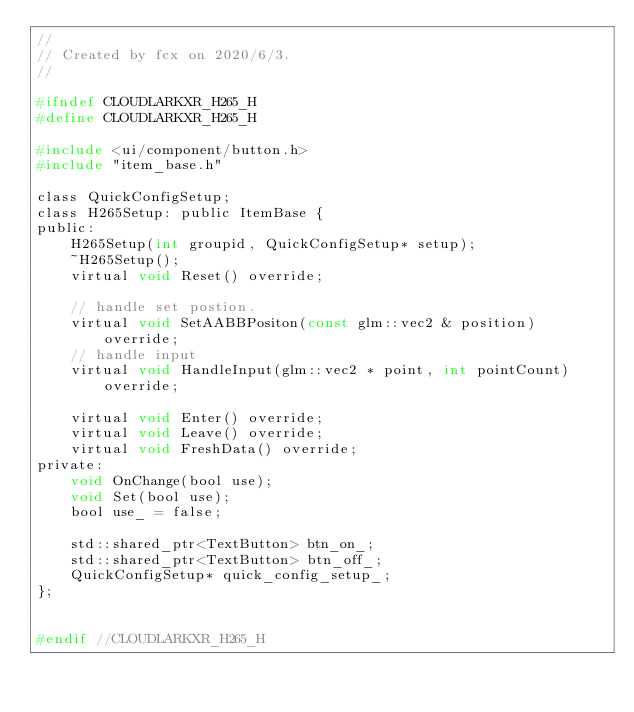Convert code to text. <code><loc_0><loc_0><loc_500><loc_500><_C_>//
// Created by fcx on 2020/6/3.
//

#ifndef CLOUDLARKXR_H265_H
#define CLOUDLARKXR_H265_H

#include <ui/component/button.h>
#include "item_base.h"

class QuickConfigSetup;
class H265Setup: public ItemBase {
public:
    H265Setup(int groupid, QuickConfigSetup* setup);
    ~H265Setup();
    virtual void Reset() override;

    // handle set postion.
    virtual void SetAABBPositon(const glm::vec2 & position) override;
    // handle input
    virtual void HandleInput(glm::vec2 * point, int pointCount) override;

    virtual void Enter() override;
    virtual void Leave() override;
    virtual void FreshData() override;
private:
    void OnChange(bool use);
    void Set(bool use);
    bool use_ = false;

    std::shared_ptr<TextButton> btn_on_;
    std::shared_ptr<TextButton> btn_off_;
    QuickConfigSetup* quick_config_setup_;
};


#endif //CLOUDLARKXR_H265_H
</code> 